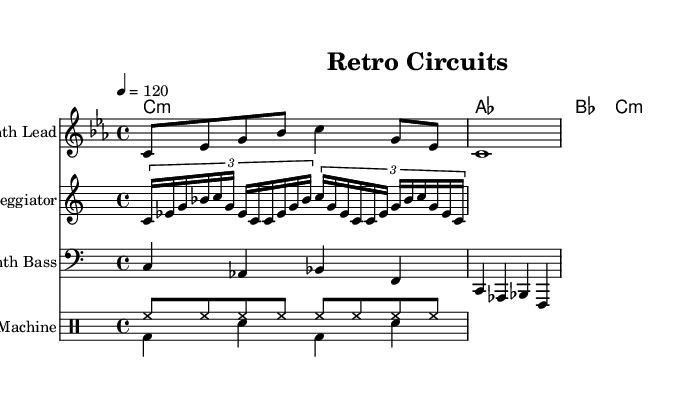What is the key signature of this music? The key signature is C minor, which has three flats (B♭, E♭, A♭). This is determined from the global section of the LilyPond code where it specifies \key c \minor.
Answer: C minor What is the time signature of this music? The time signature is 4/4, indicated in the global section of the LilyPond code with \time 4/4. This means there are four beats in a measure and a quarter note gets one beat.
Answer: 4/4 What is the tempo marking of this music? The tempo marking is 120 beats per minute, which is indicated by the line \tempo 4 = 120 in the global section of the code. This setting suggests a moderately fast pace for the piece.
Answer: 120 What type of instrument is used for the melody? The instrument used for the melody is indicated as "Synth Lead" in the staff declaration within the score. This suggests a prominent synthesizer sound for the main melody line.
Answer: Synth Lead How many voices are used in the drum section? There are two voices used in the drum section, as indicated by the through \new DrumVoice { \voiceOne ... } and \new DrumVoice { \voiceTwo ... } statements. Each voice represents a different part of the drum patterns employed in this piece.
Answer: 2 What kind of chords are played in the harmony section? The chords in the harmony section consist of various major and minor chords, such as C minor, A♭ major, and B♭ major, which can be inferred from the \harmonyChords definition in the score. This enhances the synthwave atmosphere by using rich harmonic textures.
Answer: Minor and Major chords Which rhythmic pattern is being played in the drum machine section? The rhythmic pattern played in the drum machine includes hi-hats and bass drums, as indicated in the drum patterns defined in the scores: \drummode { hh8 ... } for hi-hats and \drummode { bd4 sn ... } for bass drums and snares. This creates a driving rhythm typical of synthwave music.
Answer: Hi-hat and bass drum patterns 